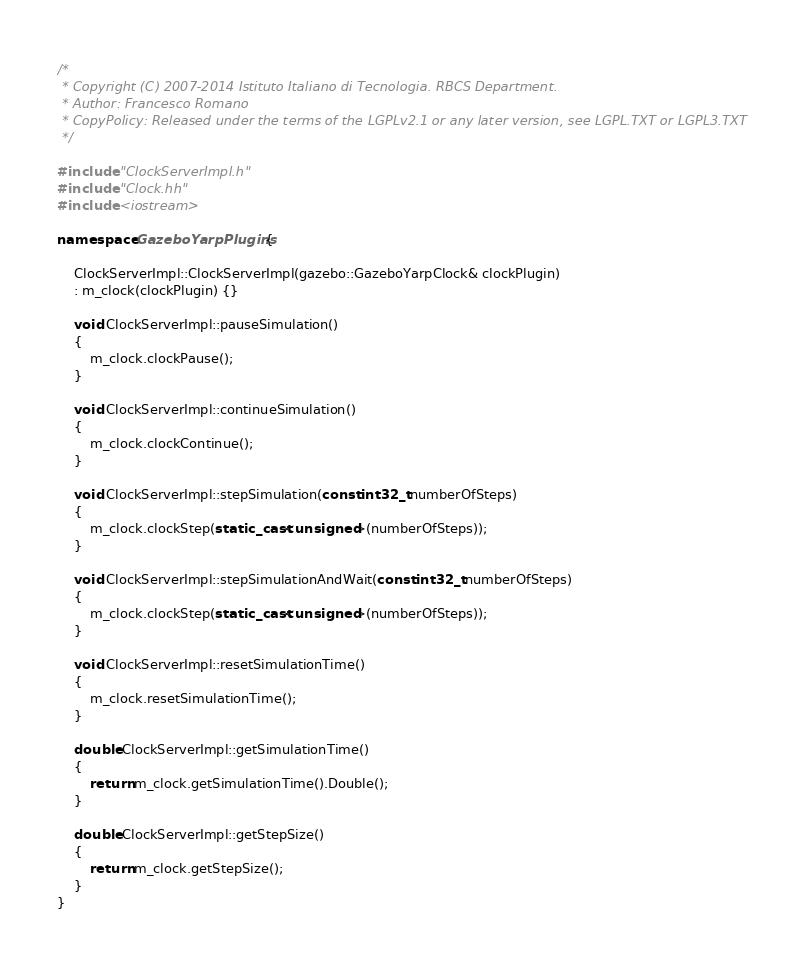Convert code to text. <code><loc_0><loc_0><loc_500><loc_500><_C++_>/*
 * Copyright (C) 2007-2014 Istituto Italiano di Tecnologia. RBCS Department.
 * Author: Francesco Romano
 * CopyPolicy: Released under the terms of the LGPLv2.1 or any later version, see LGPL.TXT or LGPL3.TXT
 */

#include "ClockServerImpl.h"
#include "Clock.hh"
#include <iostream>

namespace GazeboYarpPlugins {
    
    ClockServerImpl::ClockServerImpl(gazebo::GazeboYarpClock& clockPlugin)
    : m_clock(clockPlugin) {}
    
    void ClockServerImpl::pauseSimulation()
    {
        m_clock.clockPause();
    }
    
    void ClockServerImpl::continueSimulation()
    {
        m_clock.clockContinue();
    }

    void ClockServerImpl::stepSimulation(const int32_t numberOfSteps)
    {
        m_clock.clockStep(static_cast<unsigned>(numberOfSteps));
    }
    
    void ClockServerImpl::stepSimulationAndWait(const int32_t numberOfSteps)
    {
        m_clock.clockStep(static_cast<unsigned>(numberOfSteps));
    }
    
    void ClockServerImpl::resetSimulationTime()
    {
        m_clock.resetSimulationTime();
    }
    
    double ClockServerImpl::getSimulationTime()
    {
        return m_clock.getSimulationTime().Double();
    }
    
    double ClockServerImpl::getStepSize()
    {
        return m_clock.getStepSize();
    }
}
</code> 